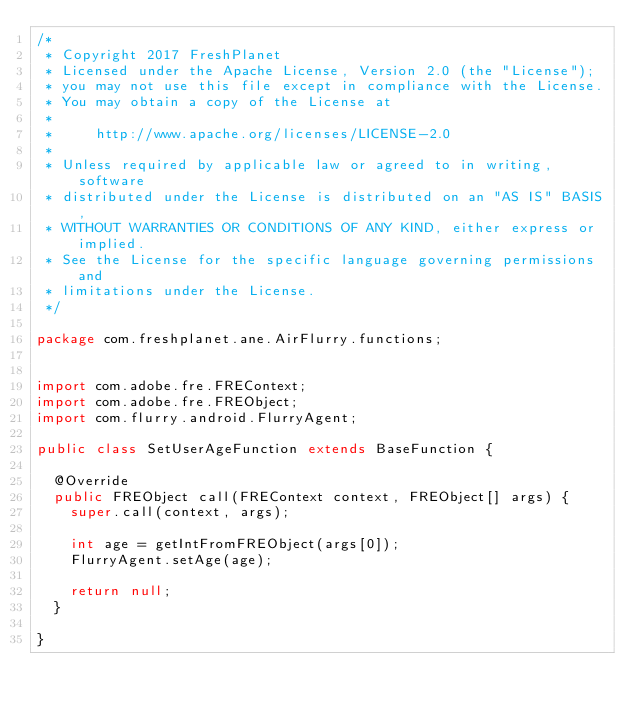<code> <loc_0><loc_0><loc_500><loc_500><_Java_>/*
 * Copyright 2017 FreshPlanet
 * Licensed under the Apache License, Version 2.0 (the "License");
 * you may not use this file except in compliance with the License.
 * You may obtain a copy of the License at
 *
 *     http://www.apache.org/licenses/LICENSE-2.0
 *
 * Unless required by applicable law or agreed to in writing, software
 * distributed under the License is distributed on an "AS IS" BASIS,
 * WITHOUT WARRANTIES OR CONDITIONS OF ANY KIND, either express or implied.
 * See the License for the specific language governing permissions and
 * limitations under the License.
 */

package com.freshplanet.ane.AirFlurry.functions;


import com.adobe.fre.FREContext;
import com.adobe.fre.FREObject;
import com.flurry.android.FlurryAgent;

public class SetUserAgeFunction extends BaseFunction {

	@Override
	public FREObject call(FREContext context, FREObject[] args) {
		super.call(context, args);

		int age = getIntFromFREObject(args[0]);
		FlurryAgent.setAge(age);

		return null;
	}

}
</code> 